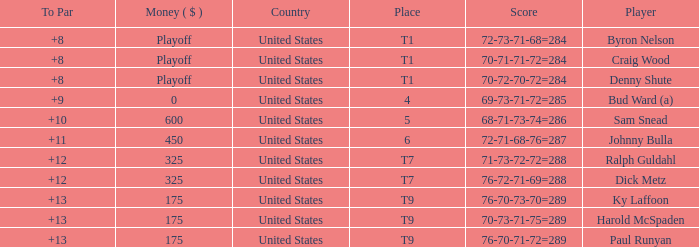What was the total To Par for Craig Wood? 8.0. Parse the table in full. {'header': ['To Par', 'Money ( $ )', 'Country', 'Place', 'Score', 'Player'], 'rows': [['+8', 'Playoff', 'United States', 'T1', '72-73-71-68=284', 'Byron Nelson'], ['+8', 'Playoff', 'United States', 'T1', '70-71-71-72=284', 'Craig Wood'], ['+8', 'Playoff', 'United States', 'T1', '70-72-70-72=284', 'Denny Shute'], ['+9', '0', 'United States', '4', '69-73-71-72=285', 'Bud Ward (a)'], ['+10', '600', 'United States', '5', '68-71-73-74=286', 'Sam Snead'], ['+11', '450', 'United States', '6', '72-71-68-76=287', 'Johnny Bulla'], ['+12', '325', 'United States', 'T7', '71-73-72-72=288', 'Ralph Guldahl'], ['+12', '325', 'United States', 'T7', '76-72-71-69=288', 'Dick Metz'], ['+13', '175', 'United States', 'T9', '76-70-73-70=289', 'Ky Laffoon'], ['+13', '175', 'United States', 'T9', '70-73-71-75=289', 'Harold McSpaden'], ['+13', '175', 'United States', 'T9', '76-70-71-72=289', 'Paul Runyan']]} 